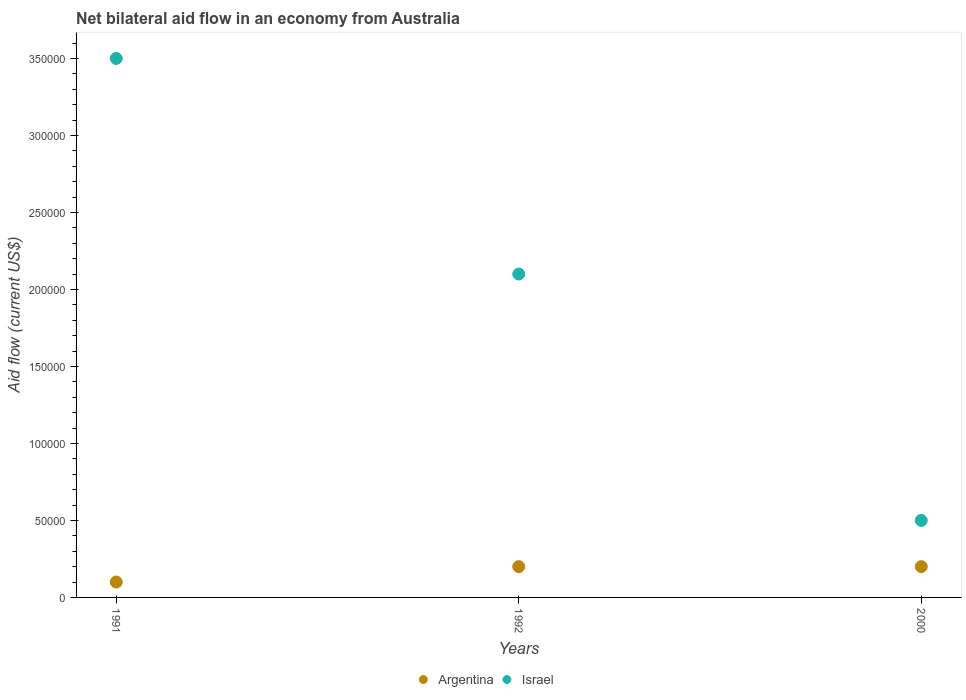How many different coloured dotlines are there?
Your answer should be very brief. 2. Is the number of dotlines equal to the number of legend labels?
Offer a terse response. Yes. What is the net bilateral aid flow in Israel in 1991?
Your answer should be compact. 3.50e+05. Across all years, what is the minimum net bilateral aid flow in Argentina?
Give a very brief answer. 10000. In which year was the net bilateral aid flow in Argentina minimum?
Provide a succinct answer. 1991. What is the difference between the net bilateral aid flow in Argentina in 1991 and that in 2000?
Give a very brief answer. -10000. What is the difference between the net bilateral aid flow in Israel in 1992 and the net bilateral aid flow in Argentina in 2000?
Provide a short and direct response. 1.90e+05. What is the average net bilateral aid flow in Israel per year?
Give a very brief answer. 2.03e+05. In the year 1992, what is the difference between the net bilateral aid flow in Argentina and net bilateral aid flow in Israel?
Your response must be concise. -1.90e+05. In how many years, is the net bilateral aid flow in Israel greater than 110000 US$?
Offer a very short reply. 2. Is the difference between the net bilateral aid flow in Argentina in 1991 and 1992 greater than the difference between the net bilateral aid flow in Israel in 1991 and 1992?
Make the answer very short. No. What is the difference between the highest and the second highest net bilateral aid flow in Israel?
Offer a terse response. 1.40e+05. How many dotlines are there?
Make the answer very short. 2. How many years are there in the graph?
Offer a very short reply. 3. What is the difference between two consecutive major ticks on the Y-axis?
Provide a succinct answer. 5.00e+04. Does the graph contain grids?
Make the answer very short. No. Where does the legend appear in the graph?
Give a very brief answer. Bottom center. How are the legend labels stacked?
Make the answer very short. Horizontal. What is the title of the graph?
Give a very brief answer. Net bilateral aid flow in an economy from Australia. Does "Czech Republic" appear as one of the legend labels in the graph?
Give a very brief answer. No. What is the label or title of the X-axis?
Ensure brevity in your answer.  Years. Across all years, what is the maximum Aid flow (current US$) in Argentina?
Ensure brevity in your answer.  2.00e+04. Across all years, what is the minimum Aid flow (current US$) of Argentina?
Provide a succinct answer. 10000. What is the total Aid flow (current US$) in Argentina in the graph?
Offer a terse response. 5.00e+04. What is the total Aid flow (current US$) of Israel in the graph?
Your response must be concise. 6.10e+05. What is the difference between the Aid flow (current US$) in Israel in 1991 and that in 1992?
Give a very brief answer. 1.40e+05. What is the difference between the Aid flow (current US$) of Argentina in 1991 and that in 2000?
Make the answer very short. -10000. What is the difference between the Aid flow (current US$) in Israel in 1991 and that in 2000?
Provide a short and direct response. 3.00e+05. What is the difference between the Aid flow (current US$) of Argentina in 1992 and that in 2000?
Keep it short and to the point. 0. What is the difference between the Aid flow (current US$) of Argentina in 1991 and the Aid flow (current US$) of Israel in 1992?
Your response must be concise. -2.00e+05. What is the average Aid flow (current US$) in Argentina per year?
Offer a very short reply. 1.67e+04. What is the average Aid flow (current US$) in Israel per year?
Your answer should be very brief. 2.03e+05. In the year 1992, what is the difference between the Aid flow (current US$) of Argentina and Aid flow (current US$) of Israel?
Offer a terse response. -1.90e+05. What is the ratio of the Aid flow (current US$) of Argentina in 1991 to that in 1992?
Your answer should be very brief. 0.5. What is the ratio of the Aid flow (current US$) of Israel in 1991 to that in 1992?
Keep it short and to the point. 1.67. What is the difference between the highest and the lowest Aid flow (current US$) of Argentina?
Your answer should be compact. 10000. 